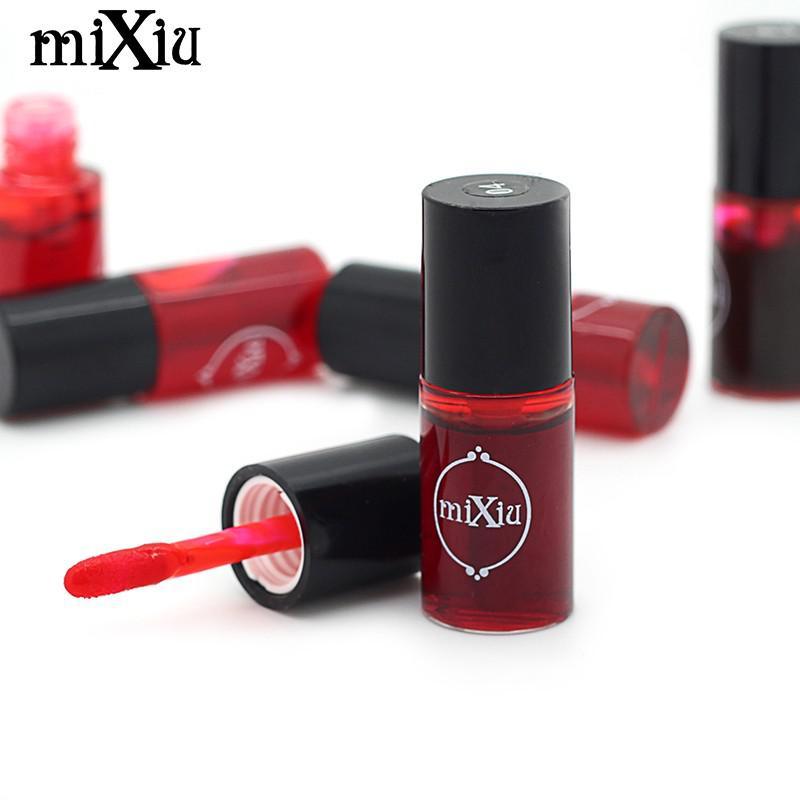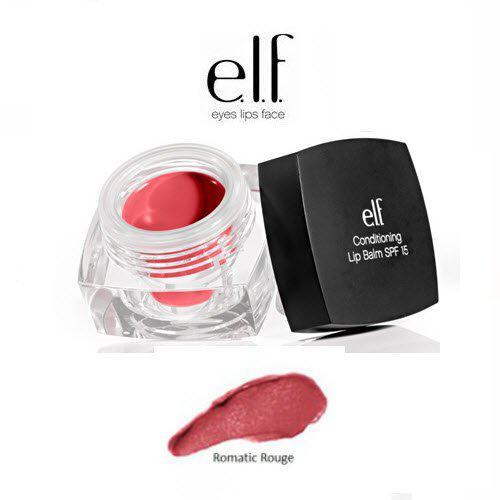The first image is the image on the left, the second image is the image on the right. Analyze the images presented: Is the assertion "The image on the right contains an opened jar with lid." valid? Answer yes or no. Yes. 